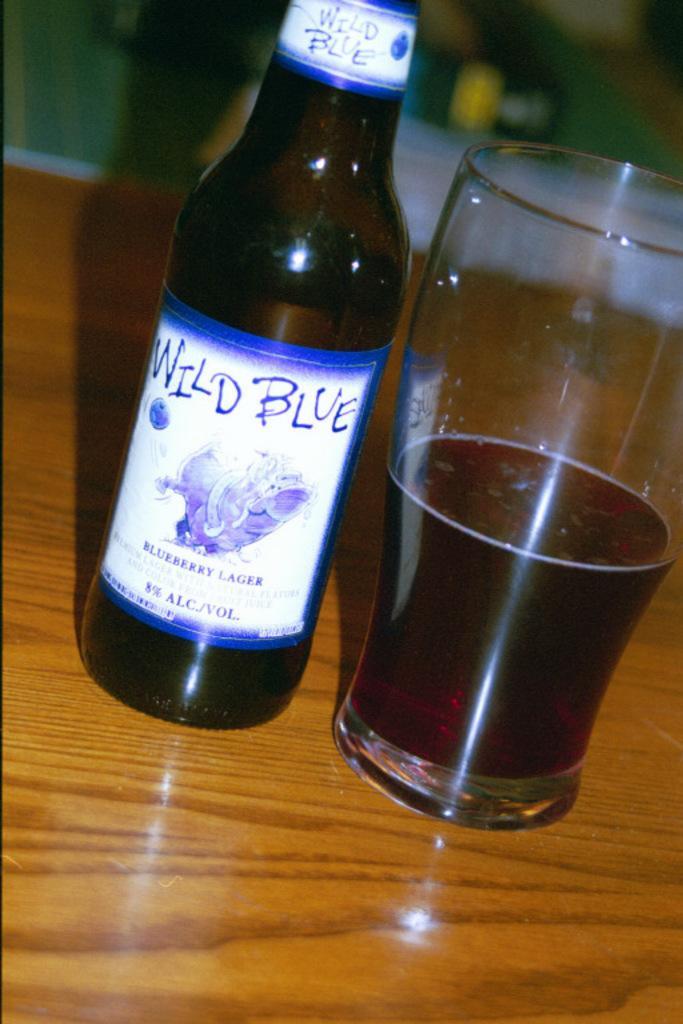In one or two sentences, can you explain what this image depicts? On this wooden surface we can see bottle and glass. In this glass there is a liquid. Background it is blur. 